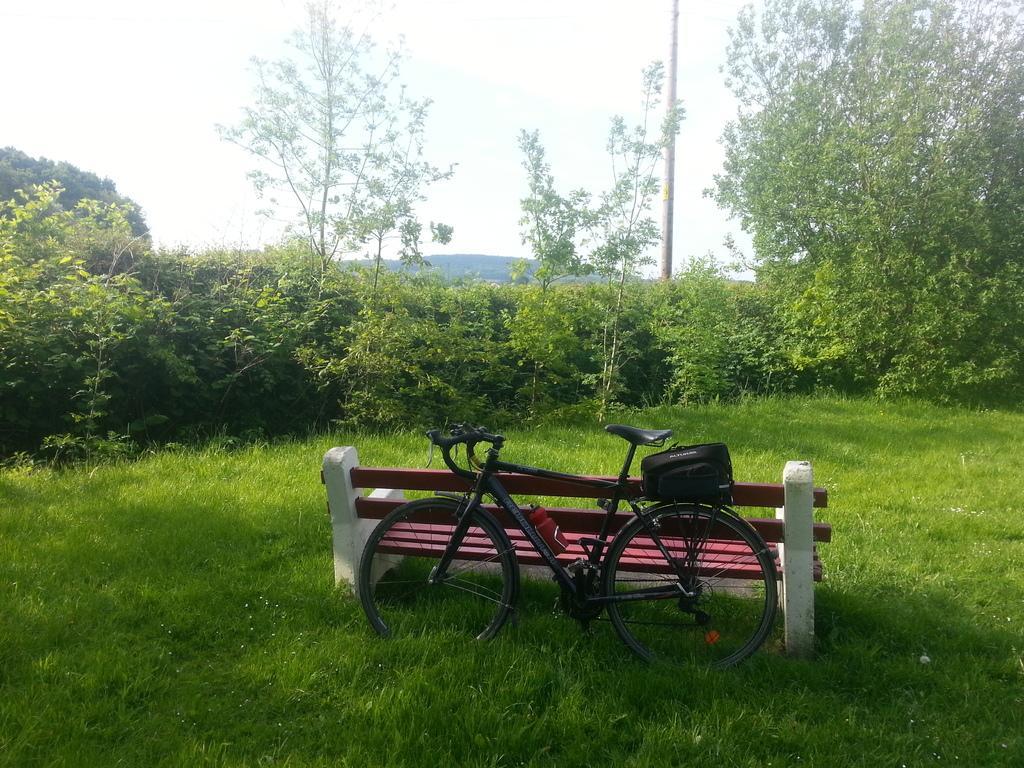Please provide a concise description of this image. In the image we can see the bench and the bicycle. Here we can see the grass, plants and trees. We can even see the pole and the sky. 